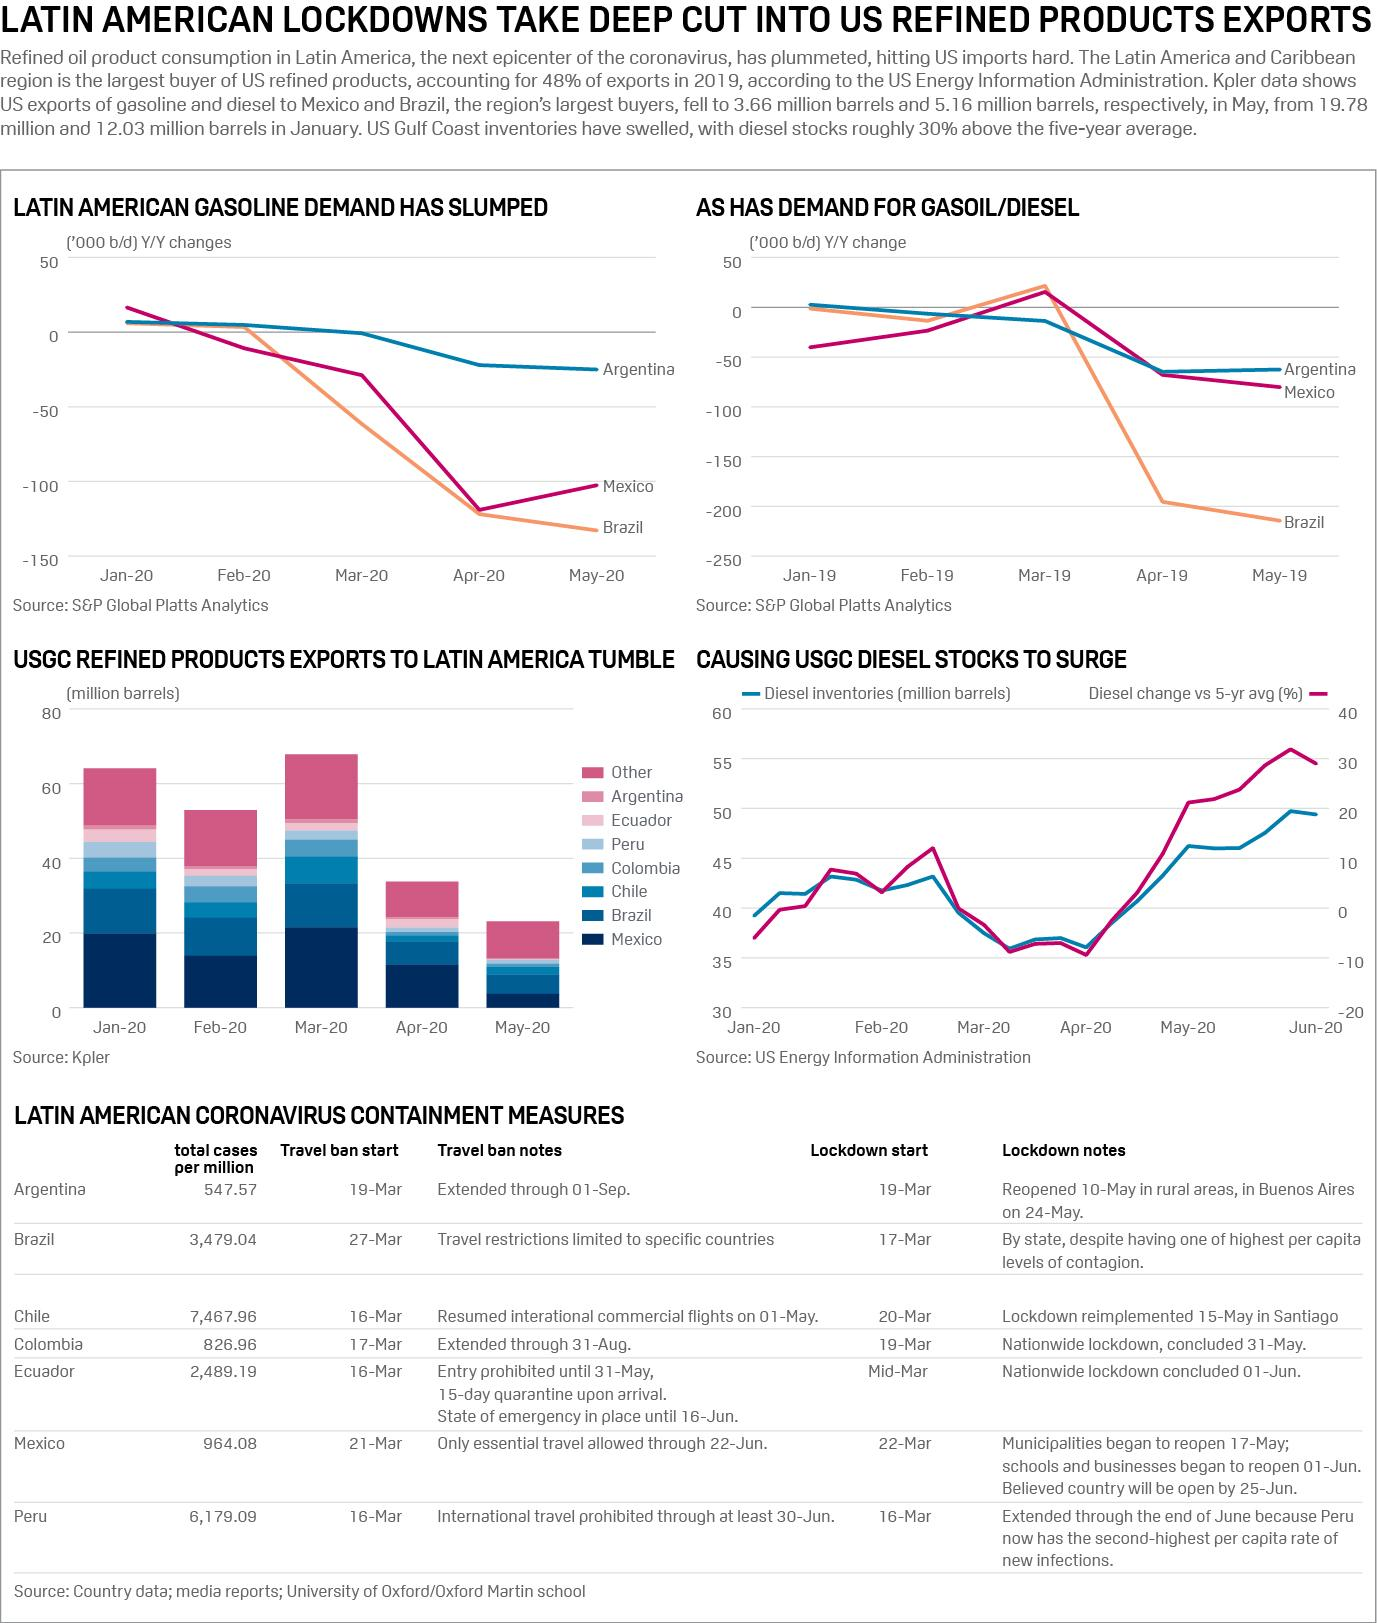Draw attention to some important aspects in this diagram. On March 20th, the lockdown due to the COVID-19 outbreak in Chile began. The lockdown due to the COVID-19 outbreak in Brazil began on March 17th. The travel ban in Peru started on March 16th. As of September 2021, the total number of COVID-19 cases per million population in Mexico is 964.08. The total number of COVID-19 cases per million population in Colombia is 826.96. 